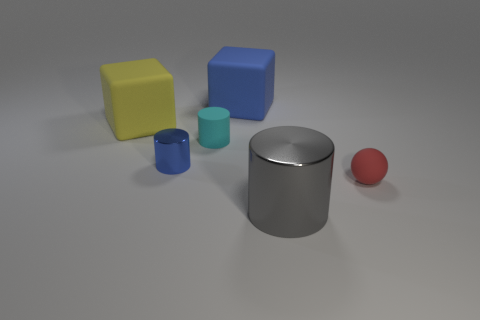What shape is the large matte object that is the same color as the small shiny object?
Offer a terse response. Cube. There is a blue object on the right side of the tiny matte thing that is to the left of the red sphere; is there a rubber thing on the left side of it?
Your response must be concise. Yes. The cyan matte thing that is the same size as the blue metal thing is what shape?
Your response must be concise. Cylinder. The other thing that is the same shape as the blue matte object is what color?
Your response must be concise. Yellow. How many objects are gray shiny cylinders or large cubes?
Your response must be concise. 3. Does the large rubber object left of the big blue matte block have the same shape as the blue object behind the cyan cylinder?
Offer a terse response. Yes. What shape is the large matte thing behind the big yellow rubber block?
Keep it short and to the point. Cube. Are there an equal number of yellow cubes in front of the tiny cyan thing and small blue things that are right of the small metal object?
Provide a short and direct response. Yes. What number of things are either blue metallic cylinders or blue objects behind the large yellow thing?
Make the answer very short. 2. What shape is the small thing that is both right of the blue cylinder and to the left of the red rubber ball?
Offer a terse response. Cylinder. 